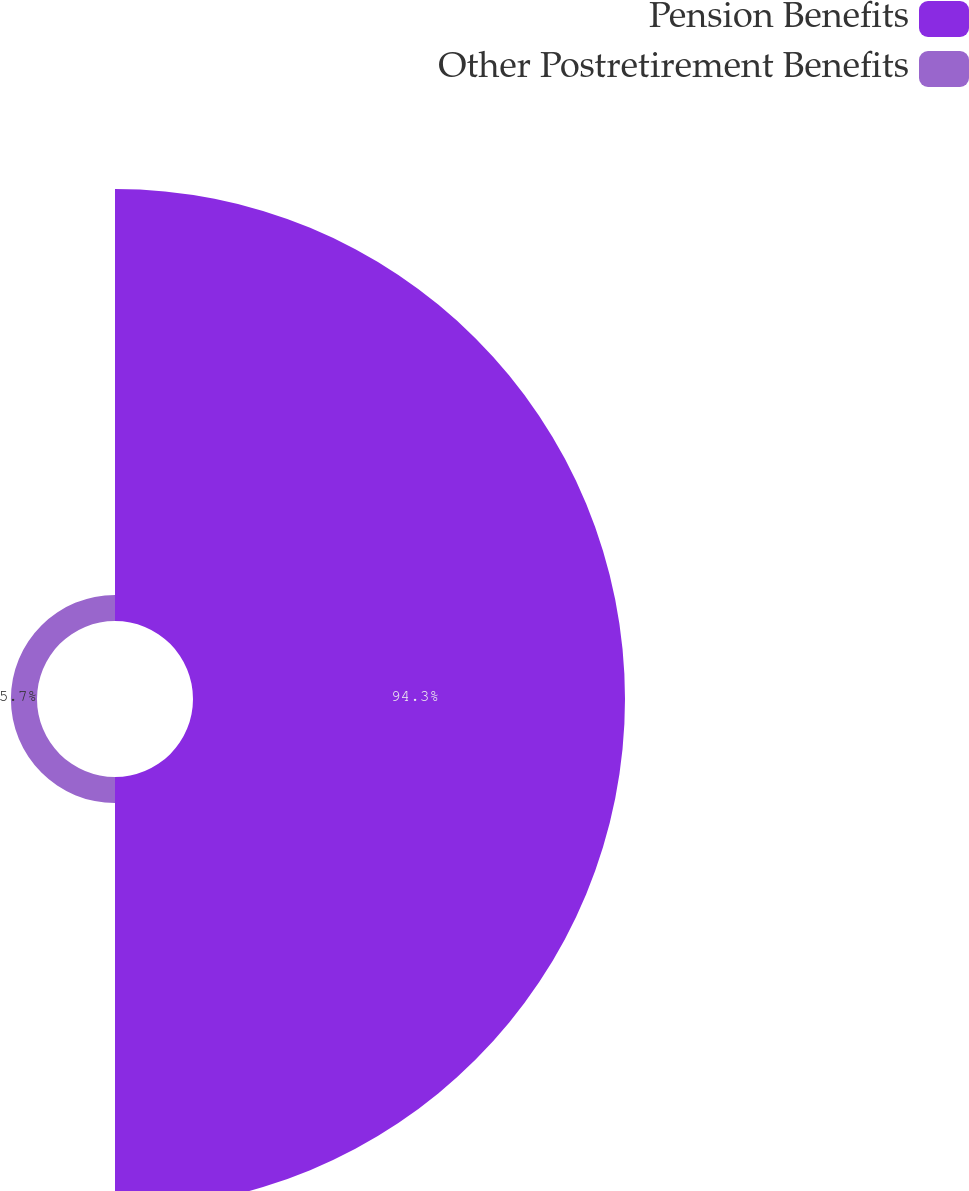<chart> <loc_0><loc_0><loc_500><loc_500><pie_chart><fcel>Pension Benefits<fcel>Other Postretirement Benefits<nl><fcel>94.3%<fcel>5.7%<nl></chart> 